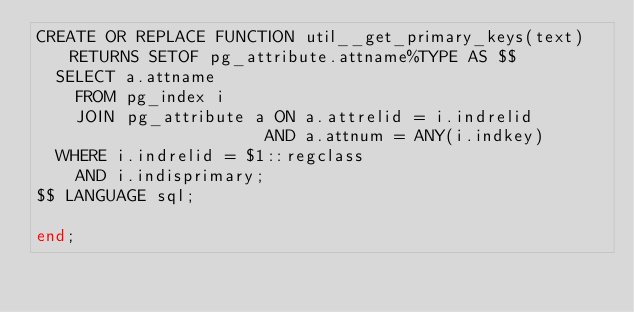<code> <loc_0><loc_0><loc_500><loc_500><_SQL_>CREATE OR REPLACE FUNCTION util__get_primary_keys(text) RETURNS SETOF pg_attribute.attname%TYPE AS $$
  SELECT a.attname
    FROM pg_index i
    JOIN pg_attribute a ON a.attrelid = i.indrelid
                       AND a.attnum = ANY(i.indkey)
  WHERE i.indrelid = $1::regclass
    AND i.indisprimary;
$$ LANGUAGE sql;

end;
</code> 